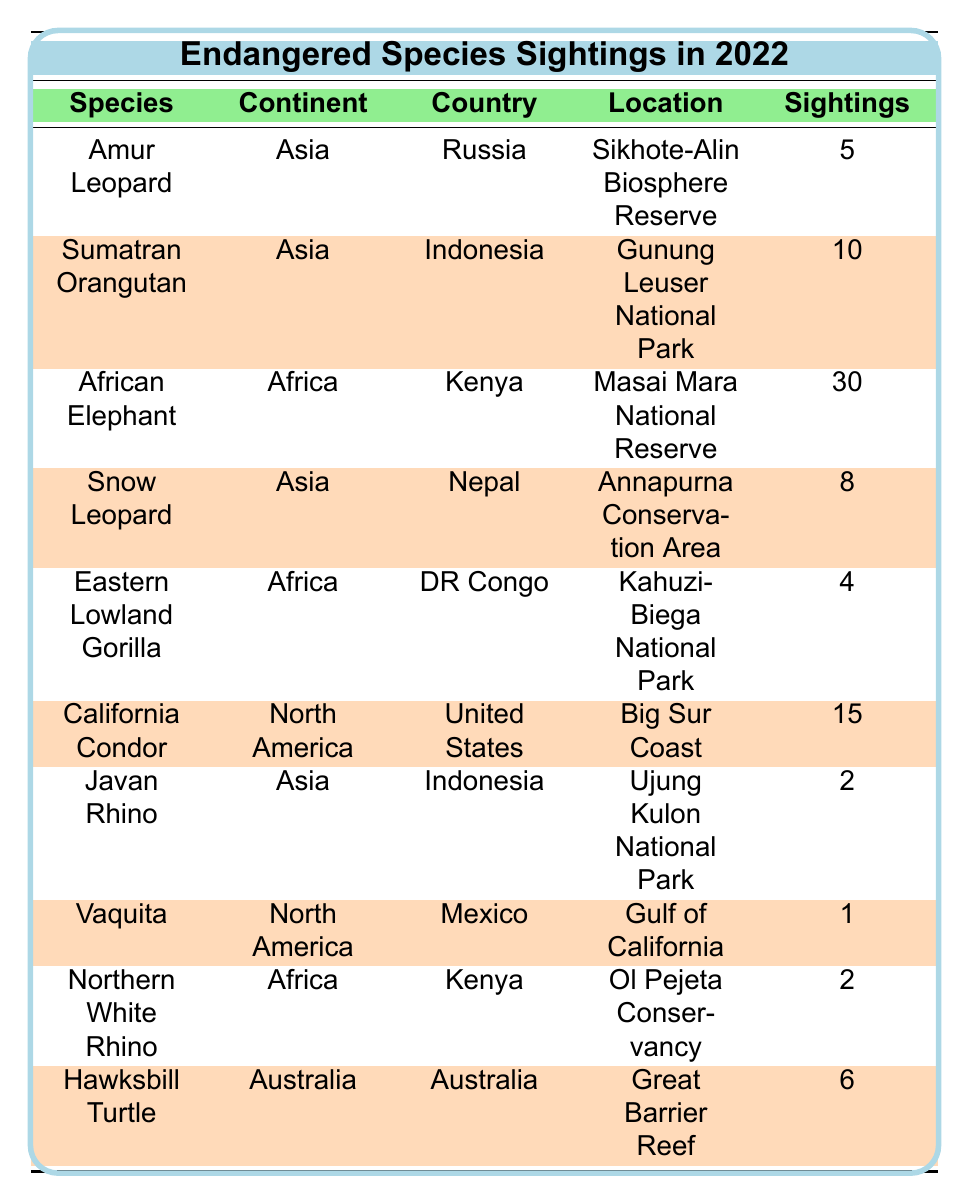What is the total number of African Elephant sightings in 2022? The table shows that there were 30 sightings of African Elephants in Kenya at the Masai Mara National Reserve.
Answer: 30 Which species had the fewest sightings in 2022? By looking at the table, the species with the fewest sightings is the Vaquita, with only 1 sighting in Mexico.
Answer: Vaquita How many endangered species sightings occurred in Asia in 2022? The table lists 5 species that were sighted in Asia: Amur Leopard, Sumatran Orangutan, Snow Leopard, and Javan Rhino. Adding those gives a total of 4 species.
Answer: 4 What is the average number of sightings of the species from Africa? The two species from Africa are the African Elephant (30 sightings) and the Eastern Lowland Gorilla (4 sightings), producing a total of 34 sightings. Thus, the average number of sightings is 34 divided by 3 species which gives us 34/3 = 11.33.
Answer: 11.33 Did more than half of the species listed have sightings in the continent of Asia? The table shows 5 species total, of which 4 are from Asia. Since 4 is more than half of 5, the answer is true.
Answer: Yes How many more sightings were there of Sumatran Orangutans than Javan Rhinos? According to the table, there were 10 sightings of Sumatran Orangutans and 2 sightings of Javan Rhinos. Therefore, the difference is 10 - 2 = 8.
Answer: 8 What was the most sighted species across all continents? The African Elephant, with 30 sightings in Kenya, is noted as having the highest number of sightings.
Answer: African Elephant Which continent had the highest number of total sightings? Adding the sightings: Africa (30 + 4 + 2 = 36), Asia (5 + 10 + 8 + 2 = 25), North America (15 + 1 = 16), and Australia (6). Africa has the most, with a total of 36 sightings.
Answer: Africa What locations were used for sightings of endangered species in North America? The table indicates two locations in North America: Big Sur Coast (California Condor) and Gulf of California (Vaquita).
Answer: Big Sur Coast and Gulf of California Was there any sighting of the Javan Rhino in 2022? The table lists a single sighting of the Javan Rhino in Indonesia, confirming that there was at least one sighting.
Answer: Yes 